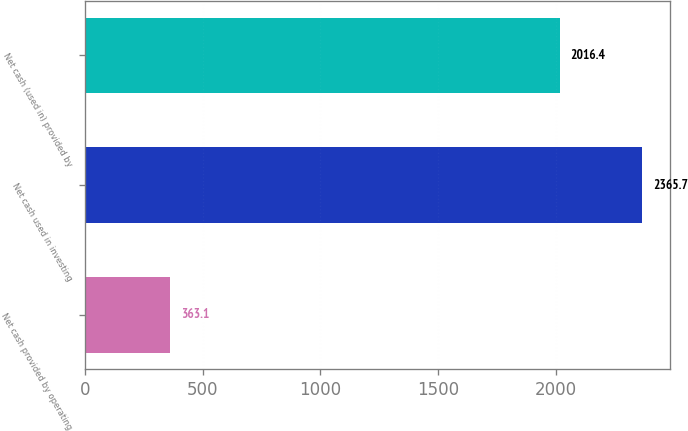<chart> <loc_0><loc_0><loc_500><loc_500><bar_chart><fcel>Net cash provided by operating<fcel>Net cash used in investing<fcel>Net cash (used in) provided by<nl><fcel>363.1<fcel>2365.7<fcel>2016.4<nl></chart> 